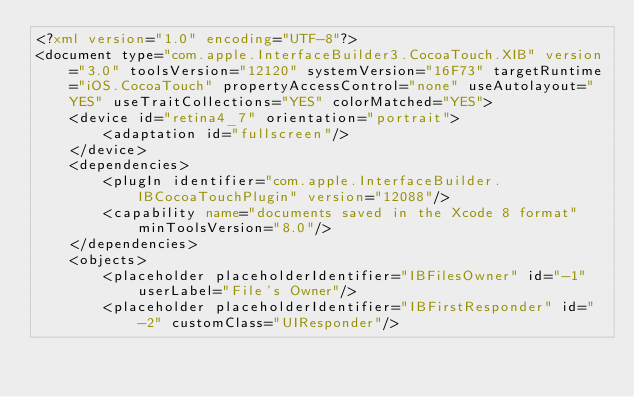<code> <loc_0><loc_0><loc_500><loc_500><_XML_><?xml version="1.0" encoding="UTF-8"?>
<document type="com.apple.InterfaceBuilder3.CocoaTouch.XIB" version="3.0" toolsVersion="12120" systemVersion="16F73" targetRuntime="iOS.CocoaTouch" propertyAccessControl="none" useAutolayout="YES" useTraitCollections="YES" colorMatched="YES">
    <device id="retina4_7" orientation="portrait">
        <adaptation id="fullscreen"/>
    </device>
    <dependencies>
        <plugIn identifier="com.apple.InterfaceBuilder.IBCocoaTouchPlugin" version="12088"/>
        <capability name="documents saved in the Xcode 8 format" minToolsVersion="8.0"/>
    </dependencies>
    <objects>
        <placeholder placeholderIdentifier="IBFilesOwner" id="-1" userLabel="File's Owner"/>
        <placeholder placeholderIdentifier="IBFirstResponder" id="-2" customClass="UIResponder"/></code> 